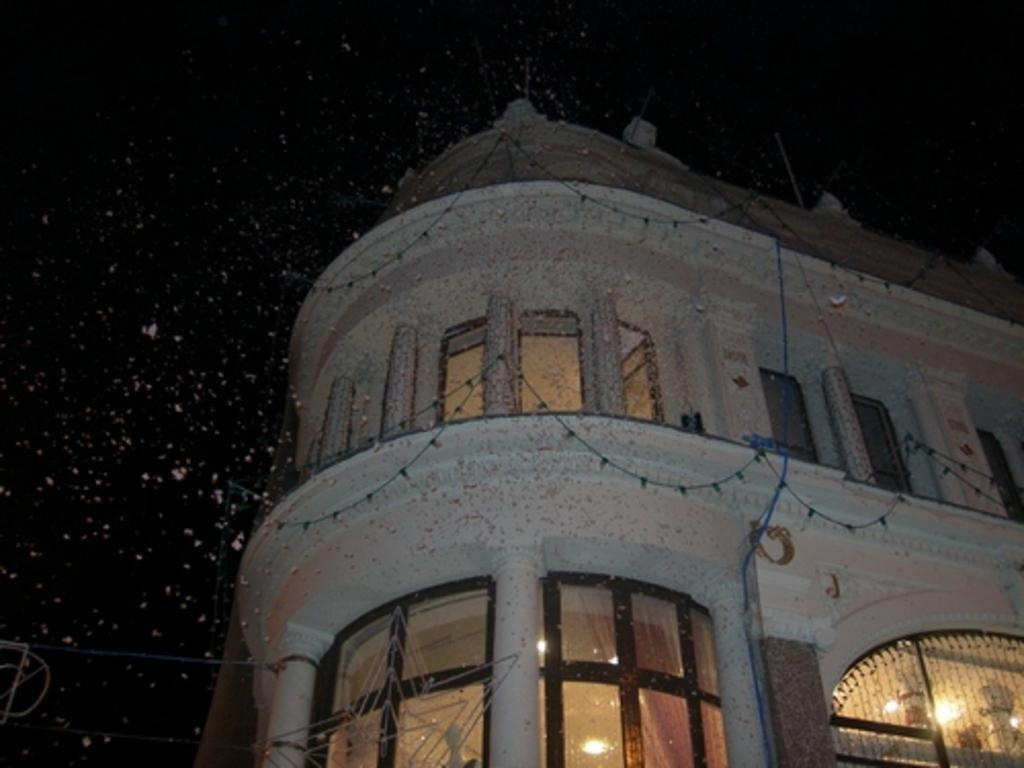What is the main subject of the picture? The main subject of the picture is a building. What features can be observed on the building? The building has windows and glass elements. What can be seen beside the building in the picture? The sky is visible beside the building. Is there a bike being ridden by someone in the picture? There is no bike or person riding a bike present in the image. Can you see any lips on the building in the picture? There are no lips depicted on the building in the image. 